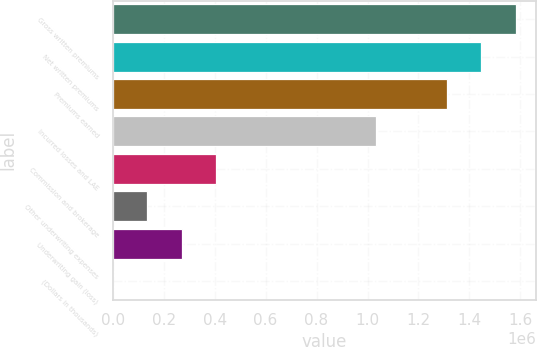<chart> <loc_0><loc_0><loc_500><loc_500><bar_chart><fcel>Gross written premiums<fcel>Net written premiums<fcel>Premiums earned<fcel>Incurred losses and LAE<fcel>Commission and brokerage<fcel>Other underwriting expenses<fcel>Underwriting gain (loss)<fcel>(Dollars in thousands)<nl><fcel>1.58168e+06<fcel>1.44719e+06<fcel>1.31271e+06<fcel>1.03411e+06<fcel>405457<fcel>136493<fcel>270975<fcel>2011<nl></chart> 